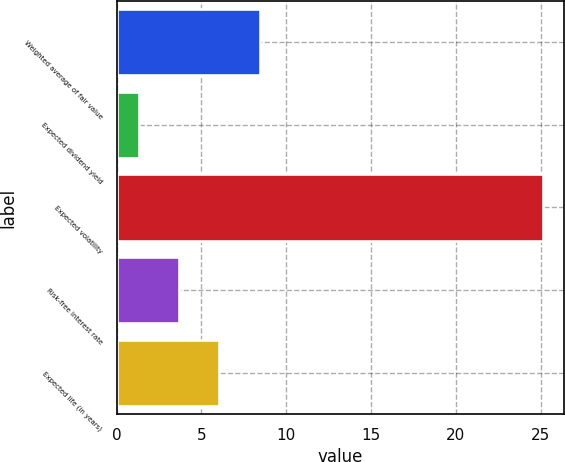Convert chart to OTSL. <chart><loc_0><loc_0><loc_500><loc_500><bar_chart><fcel>Weighted average of fair value<fcel>Expected dividend yield<fcel>Expected volatility<fcel>Risk-free interest rate<fcel>Expected life (in years)<nl><fcel>8.44<fcel>1.3<fcel>25.1<fcel>3.68<fcel>6.06<nl></chart> 